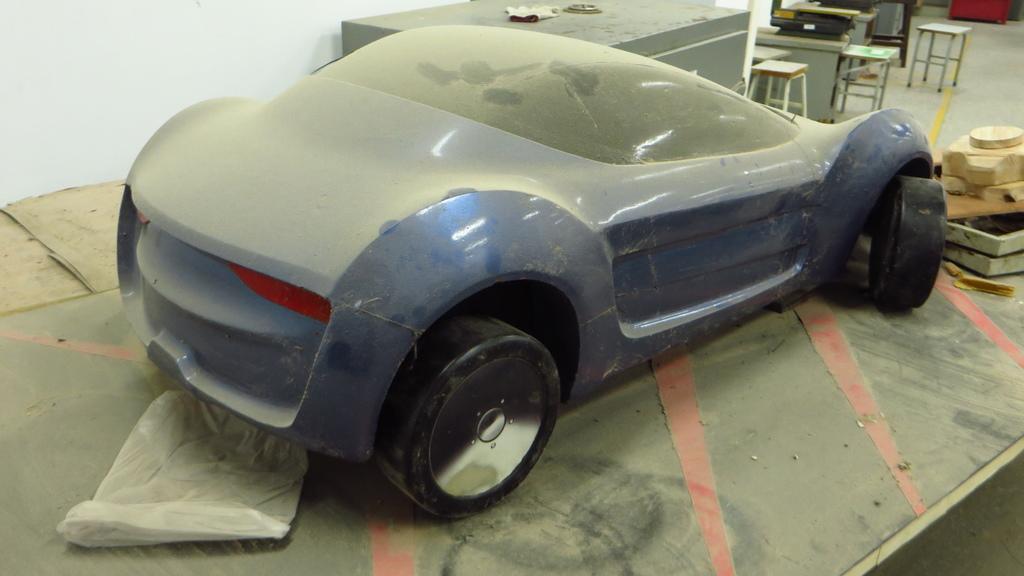In one or two sentences, can you explain what this image depicts? In this image i can see a blue color car. 